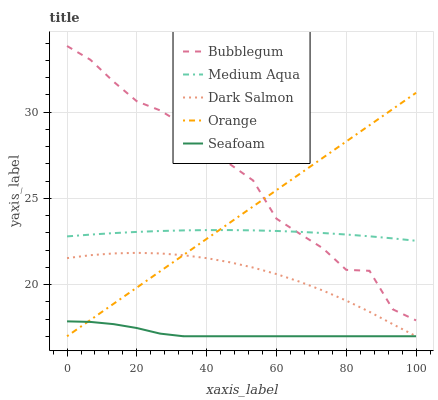Does Seafoam have the minimum area under the curve?
Answer yes or no. Yes. Does Bubblegum have the maximum area under the curve?
Answer yes or no. Yes. Does Medium Aqua have the minimum area under the curve?
Answer yes or no. No. Does Medium Aqua have the maximum area under the curve?
Answer yes or no. No. Is Orange the smoothest?
Answer yes or no. Yes. Is Bubblegum the roughest?
Answer yes or no. Yes. Is Medium Aqua the smoothest?
Answer yes or no. No. Is Medium Aqua the roughest?
Answer yes or no. No. Does Medium Aqua have the lowest value?
Answer yes or no. No. Does Bubblegum have the highest value?
Answer yes or no. Yes. Does Medium Aqua have the highest value?
Answer yes or no. No. Is Seafoam less than Medium Aqua?
Answer yes or no. Yes. Is Medium Aqua greater than Dark Salmon?
Answer yes or no. Yes. Does Bubblegum intersect Orange?
Answer yes or no. Yes. Is Bubblegum less than Orange?
Answer yes or no. No. Is Bubblegum greater than Orange?
Answer yes or no. No. Does Seafoam intersect Medium Aqua?
Answer yes or no. No. 